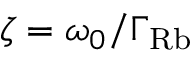Convert formula to latex. <formula><loc_0><loc_0><loc_500><loc_500>\zeta = \omega _ { 0 } / \Gamma _ { R b }</formula> 